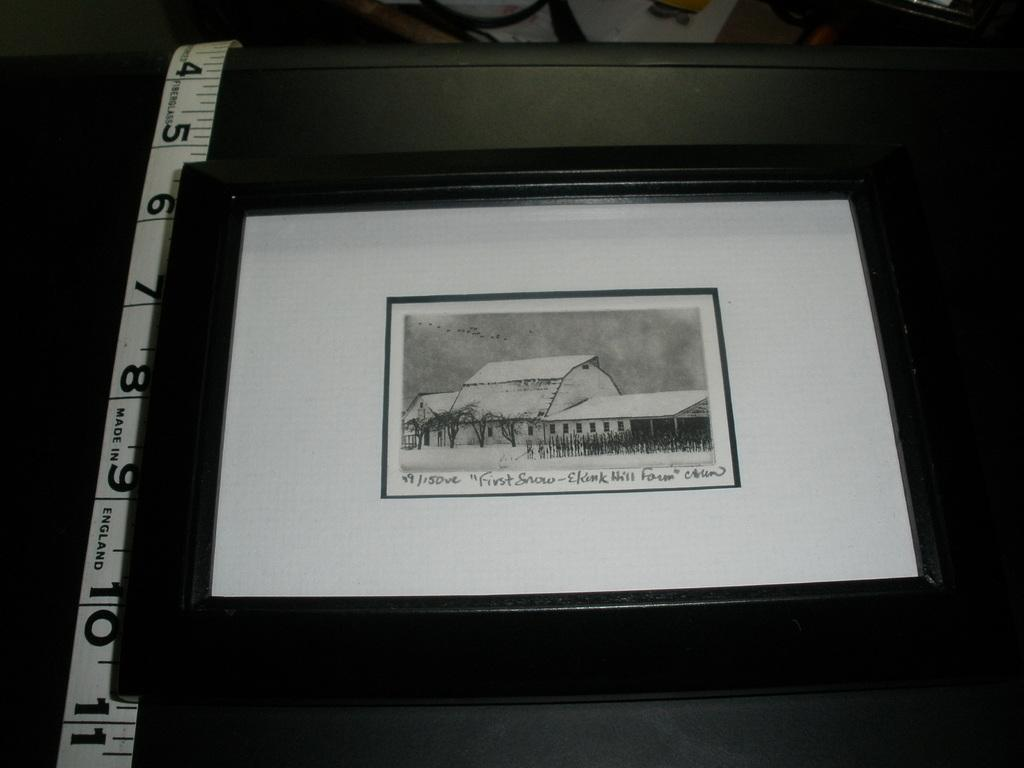Provide a one-sentence caption for the provided image. a photo of first snow in some place. 